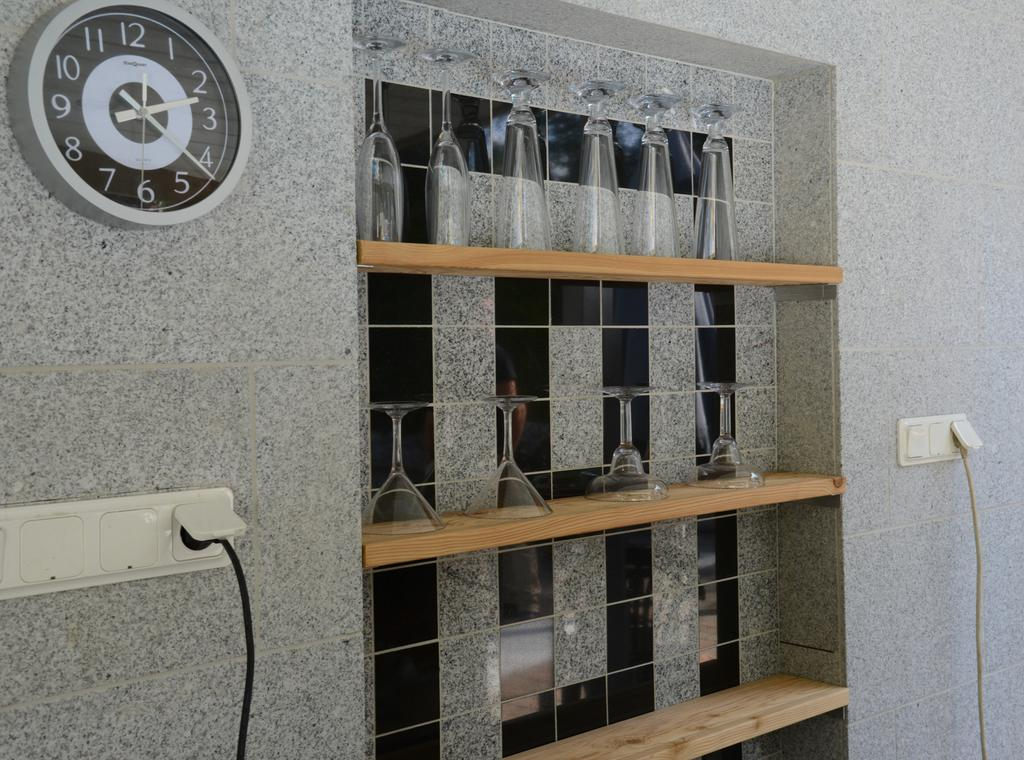<image>
Relay a brief, clear account of the picture shown. A clock with the numbers 1 through 12 on it rests on a tiled wall near cocktail glasses on a shelf. 